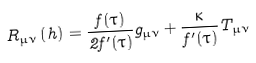<formula> <loc_0><loc_0><loc_500><loc_500>R _ { \mu \nu } \left ( h \right ) = \frac { f ( \tau ) } { 2 f ^ { \prime } ( \tau ) } g _ { \mu \nu } + \frac { \kappa } { f ^ { \prime } ( \tau ) } T _ { \mu \nu }</formula> 